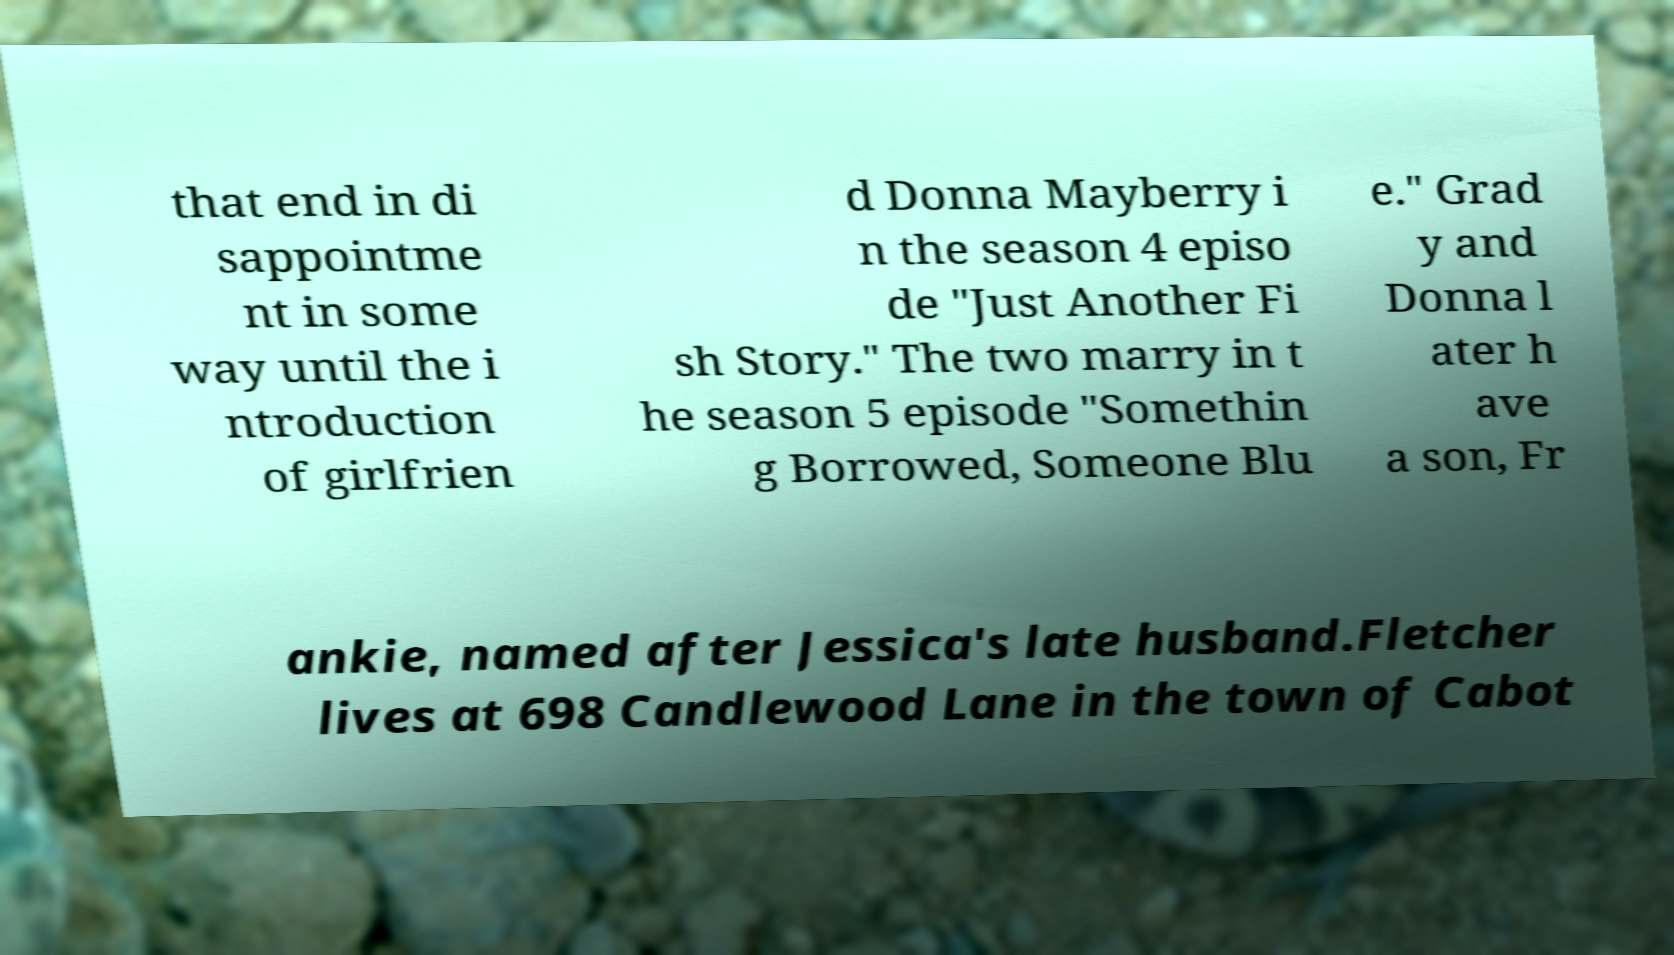For documentation purposes, I need the text within this image transcribed. Could you provide that? that end in di sappointme nt in some way until the i ntroduction of girlfrien d Donna Mayberry i n the season 4 episo de "Just Another Fi sh Story." The two marry in t he season 5 episode "Somethin g Borrowed, Someone Blu e." Grad y and Donna l ater h ave a son, Fr ankie, named after Jessica's late husband.Fletcher lives at 698 Candlewood Lane in the town of Cabot 